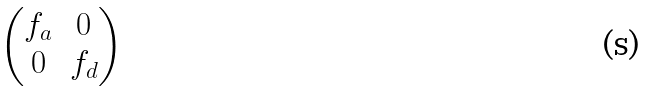Convert formula to latex. <formula><loc_0><loc_0><loc_500><loc_500>\begin{pmatrix} f _ { a } & 0 \\ 0 & f _ { d } \end{pmatrix}</formula> 